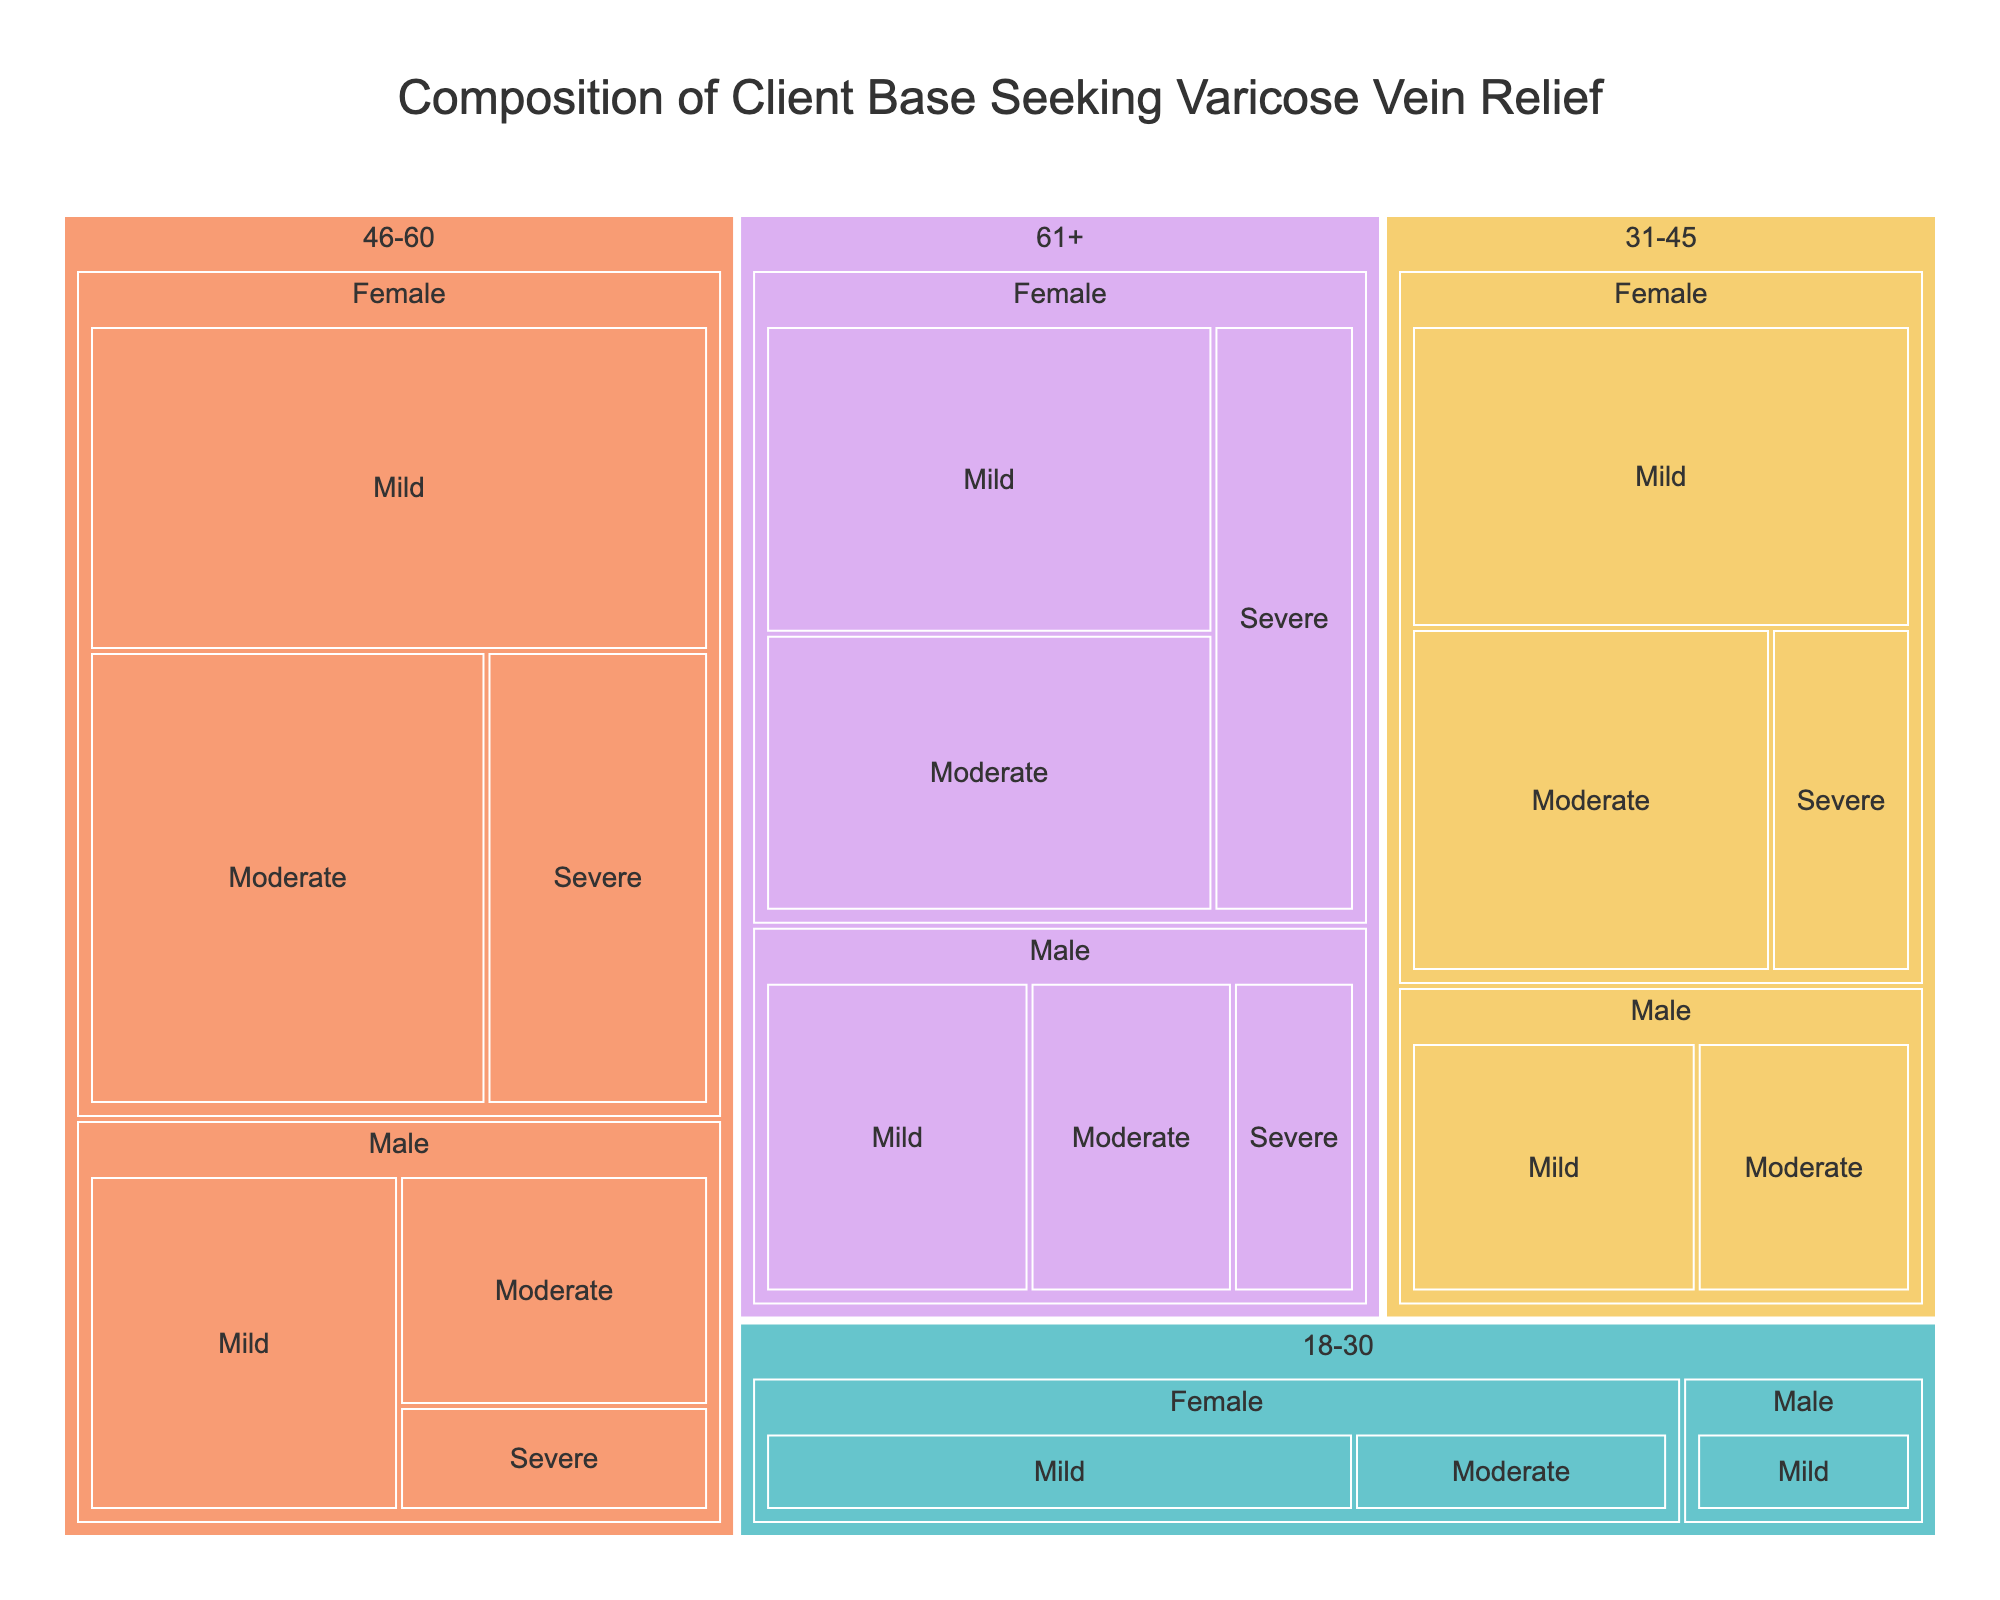what is the title of the plot? The title of the plot is usually located at the top center of the figure. It is designed to provide a quick summary of what the plot is about. In this case, the title is "Composition of Client Base Seeking Varicose Vein Relief."
Answer: Composition of Client Base Seeking Varicose Vein Relief How many clients are aged 46-60 experiencing moderate varicose vein symptoms? To find this, look for the 46-60 age group, then check for the segment labeled 'Moderate' under this age group. The number of clients is indicated within that section.
Answer: 25 Which gender has more clients aged 31-45 with severe varicose vein symptoms? First, locate the 31-45 age group. Then, compare the number of clients under the 'Severe' category for both female and male segments. The count for females is 7 and for males, it is absent, indicating females have more clients.
Answer: Female What is the total number of male clients aged 18-30? Sum the number of clients for all the severity categories for males in the 18-30 age group: Mild (6) + Moderate (0, as moderate is missing). Thus, the total is 6.
Answer: 6 Compare the number of male and female clients aged 61+ with severe symptoms. Who has more and by how much? Look at the 61+ age group and identify the severe category for both males (6) and females (12). Female clients are more by 12 - 6 = 6.
Answer: Females by 6 What's the most common severity of varicose vein symptoms among females aged 46-60? In the 46-60 age group for females, compare the number of clients across the different severity levels: Mild (28), Moderate (25), and Severe (14). The highest number is in the 'Mild' category.
Answer: Mild Which age group has the highest number of clients with mild symptoms, regardless of gender? Add up the clients with mild symptoms for each age group irrespective of gender: 18-30 (15+6=21), 31-45 (22+12=34), 46-60 (28+16=44), 61+ (20+13=33). The highest number is in the 46-60 group.
Answer: 46-60 What percentage of clients aged 31-45 are females with mild symptoms? Calculate the total number of clients in the 31-45 age group by summing all categories: (22+18+7 = 47 for females) + (12+9 = 21 for males) = 68 total. The percentage for females with mild symptoms is \( (22/68) * 100 \approx 32.35\% \).
Answer: ~32.35% Which severity level of varicose vein symptoms has the least number of clients for males aged 46-60? Check the 46-60 age group for males and compare the severity levels: Mild (16), Moderate (11), Severe (5). The least number is in the 'Severe' category.
Answer: Severe 